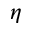Convert formula to latex. <formula><loc_0><loc_0><loc_500><loc_500>\eta</formula> 